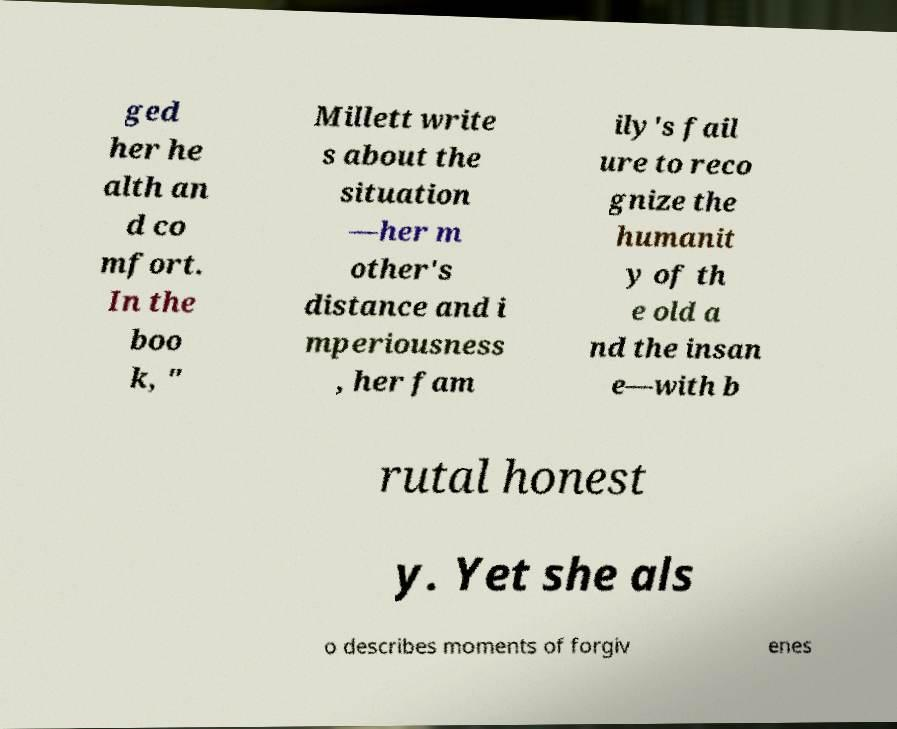There's text embedded in this image that I need extracted. Can you transcribe it verbatim? ged her he alth an d co mfort. In the boo k, " Millett write s about the situation —her m other's distance and i mperiousness , her fam ily's fail ure to reco gnize the humanit y of th e old a nd the insan e—with b rutal honest y. Yet she als o describes moments of forgiv enes 